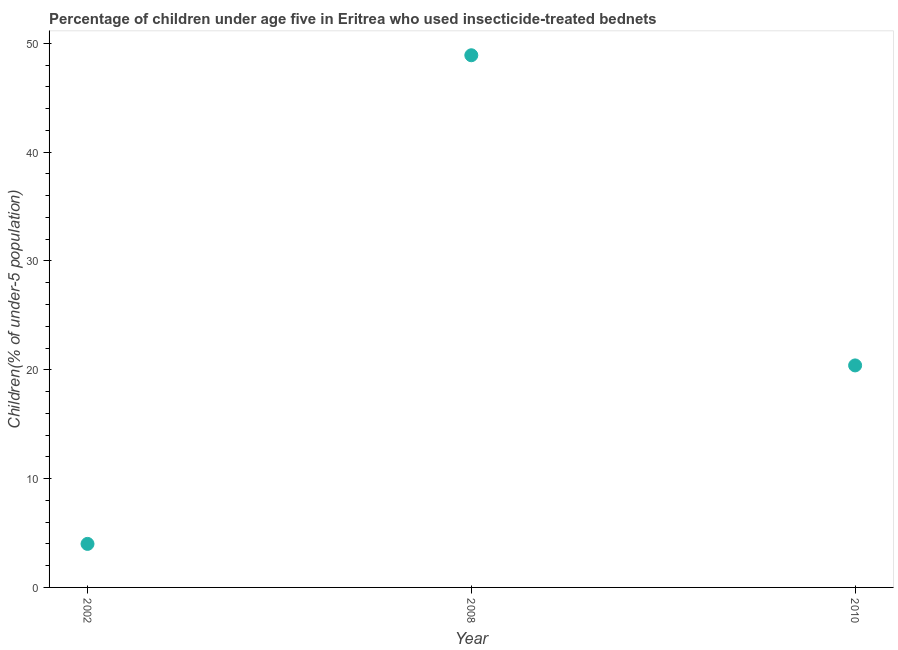What is the percentage of children who use of insecticide-treated bed nets in 2002?
Offer a terse response. 4. Across all years, what is the maximum percentage of children who use of insecticide-treated bed nets?
Provide a short and direct response. 48.9. In which year was the percentage of children who use of insecticide-treated bed nets minimum?
Provide a short and direct response. 2002. What is the sum of the percentage of children who use of insecticide-treated bed nets?
Give a very brief answer. 73.3. What is the difference between the percentage of children who use of insecticide-treated bed nets in 2002 and 2008?
Offer a terse response. -44.9. What is the average percentage of children who use of insecticide-treated bed nets per year?
Give a very brief answer. 24.43. What is the median percentage of children who use of insecticide-treated bed nets?
Ensure brevity in your answer.  20.4. In how many years, is the percentage of children who use of insecticide-treated bed nets greater than 38 %?
Keep it short and to the point. 1. Do a majority of the years between 2010 and 2002 (inclusive) have percentage of children who use of insecticide-treated bed nets greater than 18 %?
Give a very brief answer. No. What is the ratio of the percentage of children who use of insecticide-treated bed nets in 2002 to that in 2010?
Your answer should be very brief. 0.2. Is the percentage of children who use of insecticide-treated bed nets in 2008 less than that in 2010?
Make the answer very short. No. What is the difference between the highest and the second highest percentage of children who use of insecticide-treated bed nets?
Your answer should be very brief. 28.5. What is the difference between the highest and the lowest percentage of children who use of insecticide-treated bed nets?
Provide a succinct answer. 44.9. In how many years, is the percentage of children who use of insecticide-treated bed nets greater than the average percentage of children who use of insecticide-treated bed nets taken over all years?
Offer a terse response. 1. How many dotlines are there?
Keep it short and to the point. 1. What is the difference between two consecutive major ticks on the Y-axis?
Provide a short and direct response. 10. Are the values on the major ticks of Y-axis written in scientific E-notation?
Make the answer very short. No. Does the graph contain any zero values?
Provide a succinct answer. No. Does the graph contain grids?
Make the answer very short. No. What is the title of the graph?
Provide a short and direct response. Percentage of children under age five in Eritrea who used insecticide-treated bednets. What is the label or title of the Y-axis?
Provide a succinct answer. Children(% of under-5 population). What is the Children(% of under-5 population) in 2002?
Your answer should be very brief. 4. What is the Children(% of under-5 population) in 2008?
Keep it short and to the point. 48.9. What is the Children(% of under-5 population) in 2010?
Make the answer very short. 20.4. What is the difference between the Children(% of under-5 population) in 2002 and 2008?
Keep it short and to the point. -44.9. What is the difference between the Children(% of under-5 population) in 2002 and 2010?
Offer a very short reply. -16.4. What is the difference between the Children(% of under-5 population) in 2008 and 2010?
Your answer should be compact. 28.5. What is the ratio of the Children(% of under-5 population) in 2002 to that in 2008?
Your response must be concise. 0.08. What is the ratio of the Children(% of under-5 population) in 2002 to that in 2010?
Give a very brief answer. 0.2. What is the ratio of the Children(% of under-5 population) in 2008 to that in 2010?
Offer a terse response. 2.4. 